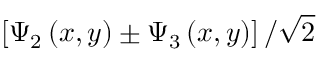<formula> <loc_0><loc_0><loc_500><loc_500>\left [ \Psi _ { 2 } \left ( x , y \right ) \pm \Psi _ { 3 } \left ( x , y \right ) \right ] / \sqrt { 2 }</formula> 